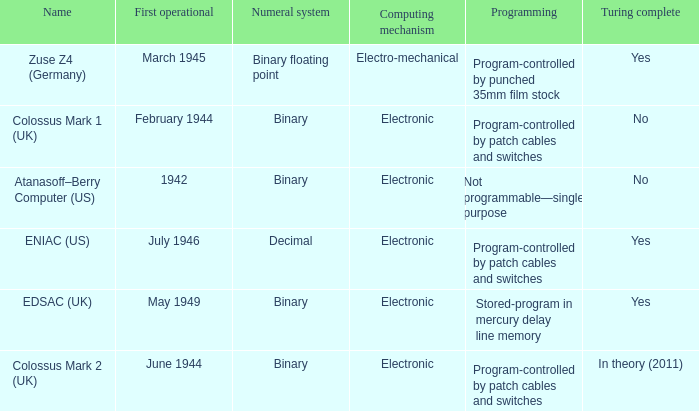What is the computing mechanism that first became operational in february 1944? Electronic. 